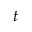<formula> <loc_0><loc_0><loc_500><loc_500>t</formula> 